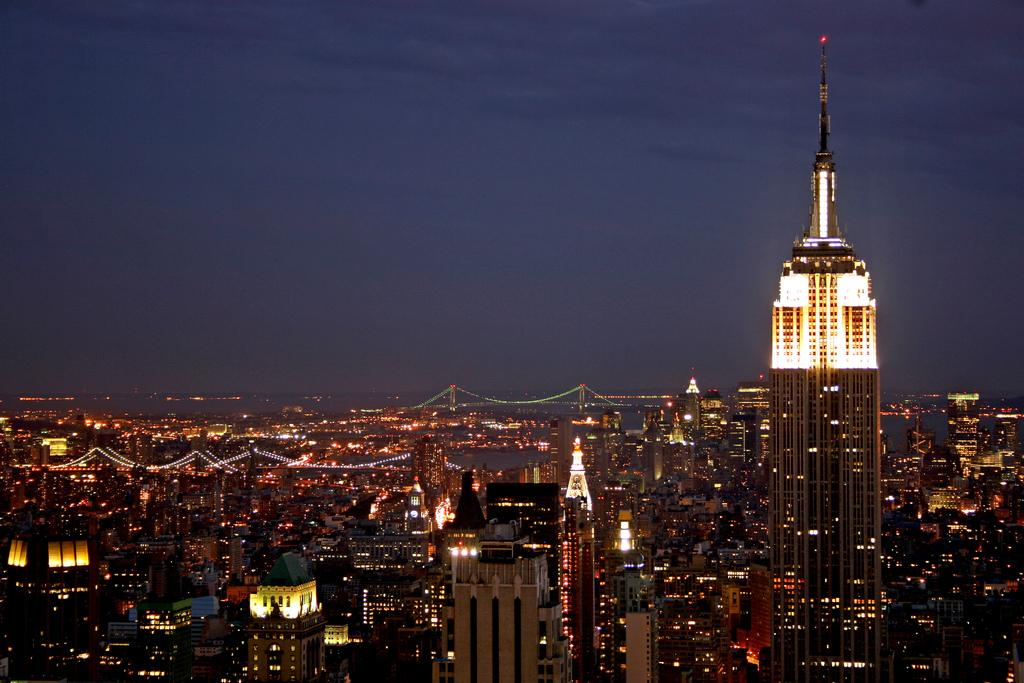What type of structures can be seen in the image? There are multiple buildings in the image. Are there any distinguishing features on the buildings? Yes, there are lights on the buildings. What type of architectural elements are present in the image? There are bridges in the image. What natural element is visible in the image? There is water visible in the image. What can be seen in the background of the image? The sky is visible in the background of the image. What type of leaf is being used for teaching in the image? There is no leaf or teaching activity present in the image. 